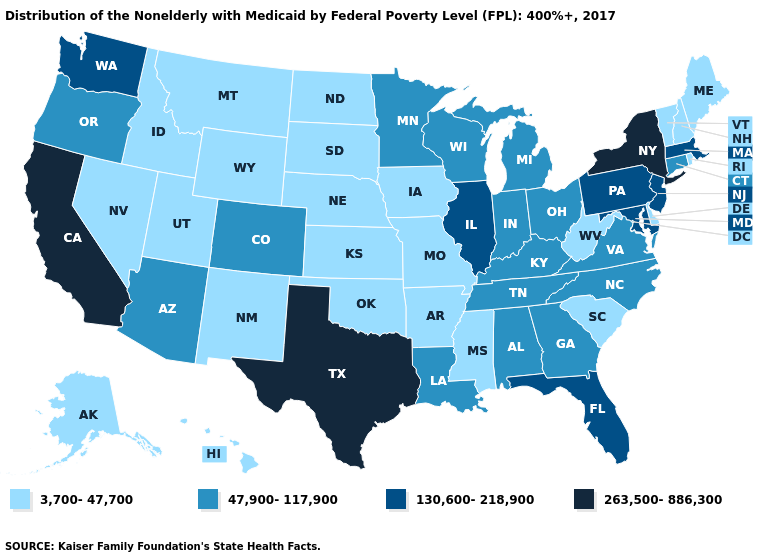Does Vermont have the lowest value in the USA?
Quick response, please. Yes. What is the value of Oklahoma?
Write a very short answer. 3,700-47,700. Name the states that have a value in the range 263,500-886,300?
Short answer required. California, New York, Texas. Name the states that have a value in the range 3,700-47,700?
Quick response, please. Alaska, Arkansas, Delaware, Hawaii, Idaho, Iowa, Kansas, Maine, Mississippi, Missouri, Montana, Nebraska, Nevada, New Hampshire, New Mexico, North Dakota, Oklahoma, Rhode Island, South Carolina, South Dakota, Utah, Vermont, West Virginia, Wyoming. What is the value of Mississippi?
Concise answer only. 3,700-47,700. Which states have the highest value in the USA?
Answer briefly. California, New York, Texas. Does Utah have the same value as Colorado?
Quick response, please. No. Name the states that have a value in the range 47,900-117,900?
Short answer required. Alabama, Arizona, Colorado, Connecticut, Georgia, Indiana, Kentucky, Louisiana, Michigan, Minnesota, North Carolina, Ohio, Oregon, Tennessee, Virginia, Wisconsin. Which states hav the highest value in the West?
Concise answer only. California. Name the states that have a value in the range 263,500-886,300?
Write a very short answer. California, New York, Texas. Does California have the highest value in the West?
Keep it brief. Yes. Does Colorado have a lower value than New York?
Quick response, please. Yes. Which states hav the highest value in the South?
Give a very brief answer. Texas. How many symbols are there in the legend?
Quick response, please. 4. 